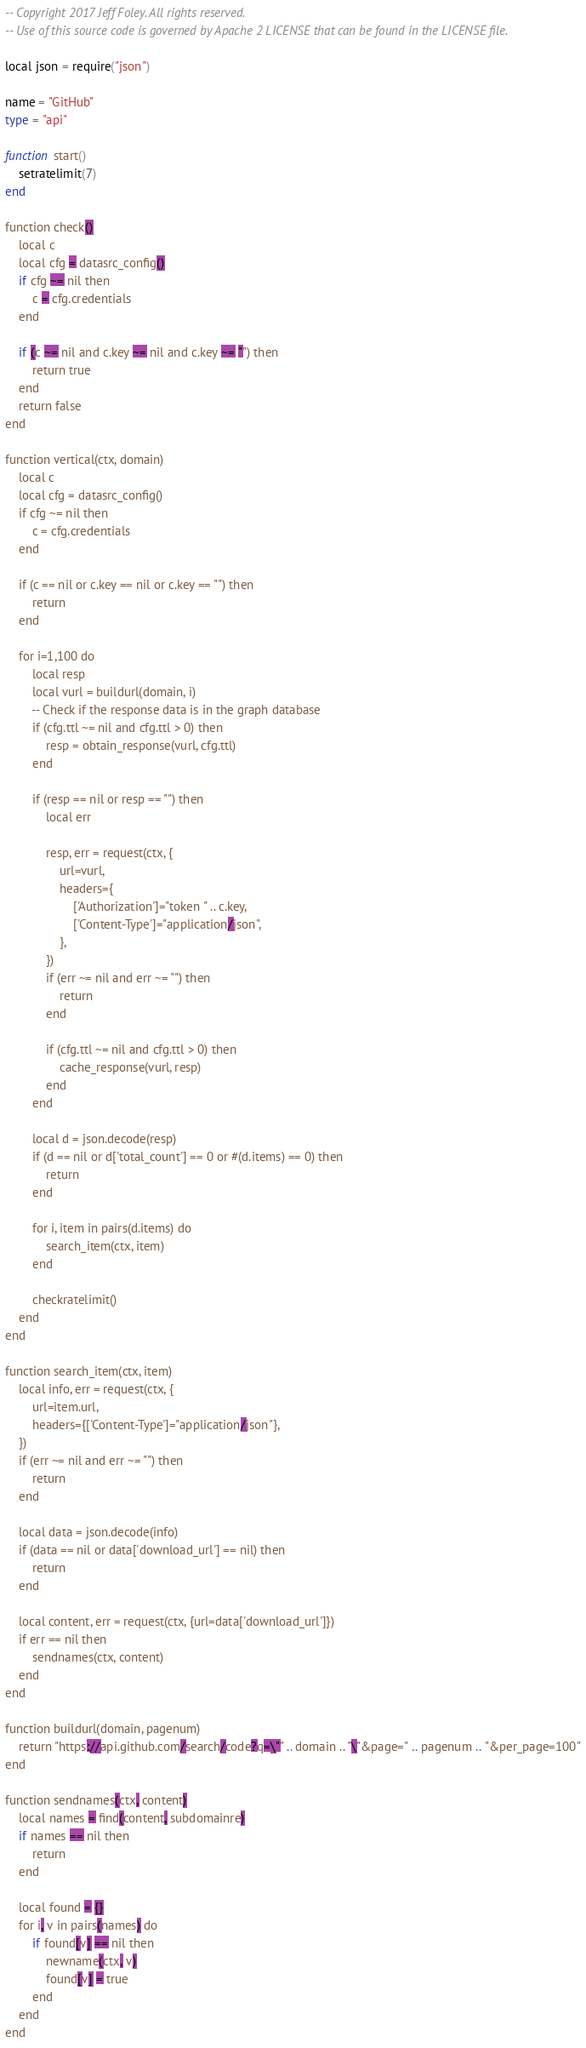<code> <loc_0><loc_0><loc_500><loc_500><_Ada_>-- Copyright 2017 Jeff Foley. All rights reserved.
-- Use of this source code is governed by Apache 2 LICENSE that can be found in the LICENSE file.

local json = require("json")

name = "GitHub"
type = "api"

function start()
    setratelimit(7)
end

function check()
    local c
    local cfg = datasrc_config()
    if cfg ~= nil then
        c = cfg.credentials
    end

    if (c ~= nil and c.key ~= nil and c.key ~= "") then
        return true
    end
    return false
end

function vertical(ctx, domain)
    local c
    local cfg = datasrc_config()
    if cfg ~= nil then
        c = cfg.credentials
    end

    if (c == nil or c.key == nil or c.key == "") then
        return
    end

    for i=1,100 do
        local resp
        local vurl = buildurl(domain, i)
        -- Check if the response data is in the graph database
        if (cfg.ttl ~= nil and cfg.ttl > 0) then
            resp = obtain_response(vurl, cfg.ttl)
        end

        if (resp == nil or resp == "") then
            local err

            resp, err = request(ctx, {
                url=vurl,
                headers={
                    ['Authorization']="token " .. c.key,
                    ['Content-Type']="application/json",
                },
            })
            if (err ~= nil and err ~= "") then
                return
            end

            if (cfg.ttl ~= nil and cfg.ttl > 0) then
                cache_response(vurl, resp)
            end
        end

        local d = json.decode(resp)
        if (d == nil or d['total_count'] == 0 or #(d.items) == 0) then
            return
        end

        for i, item in pairs(d.items) do
            search_item(ctx, item)
        end

        checkratelimit()
    end
end

function search_item(ctx, item)
    local info, err = request(ctx, {
        url=item.url,
        headers={['Content-Type']="application/json"},
    })
    if (err ~= nil and err ~= "") then
        return
    end

    local data = json.decode(info)
    if (data == nil or data['download_url'] == nil) then
        return
    end

    local content, err = request(ctx, {url=data['download_url']})
    if err == nil then
        sendnames(ctx, content)
    end
end

function buildurl(domain, pagenum)
    return "https://api.github.com/search/code?q=\"" .. domain .. "\"&page=" .. pagenum .. "&per_page=100"
end

function sendnames(ctx, content)
    local names = find(content, subdomainre)
    if names == nil then
        return
    end

    local found = {}
    for i, v in pairs(names) do
        if found[v] == nil then
            newname(ctx, v)
            found[v] = true
        end
    end
end
</code> 